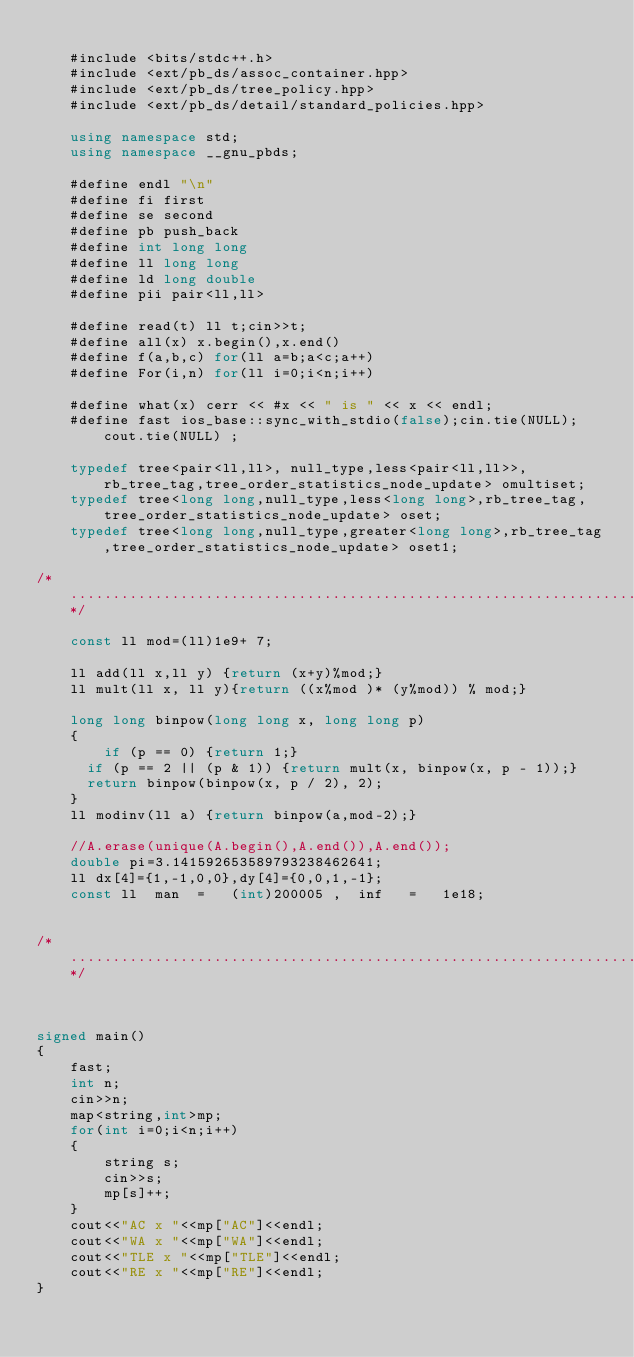<code> <loc_0><loc_0><loc_500><loc_500><_C++_> 
    #include <bits/stdc++.h>
    #include <ext/pb_ds/assoc_container.hpp>
    #include <ext/pb_ds/tree_policy.hpp>
    #include <ext/pb_ds/detail/standard_policies.hpp>
 
    using namespace std;
    using namespace __gnu_pbds;
 
    #define endl "\n"
    #define fi first
    #define se second
    #define pb push_back
    #define int long long
    #define ll long long
    #define ld long double
    #define pii pair<ll,ll>
 
    #define read(t) ll t;cin>>t;
    #define all(x) x.begin(),x.end()
    #define f(a,b,c) for(ll a=b;a<c;a++)
    #define For(i,n) for(ll i=0;i<n;i++)
 
    #define what(x) cerr << #x << " is " << x << endl;
    #define fast ios_base::sync_with_stdio(false);cin.tie(NULL);cout.tie(NULL) ;
 
    typedef tree<pair<ll,ll>, null_type,less<pair<ll,ll>>, rb_tree_tag,tree_order_statistics_node_update> omultiset;
    typedef tree<long long,null_type,less<long long>,rb_tree_tag,tree_order_statistics_node_update> oset;
    typedef tree<long long,null_type,greater<long long>,rb_tree_tag,tree_order_statistics_node_update> oset1;
 
/*.....................................................................................................................*/
 
    const ll mod=(ll)1e9+ 7;
 
    ll add(ll x,ll y) {return (x+y)%mod;}
    ll mult(ll x, ll y){return ((x%mod )* (y%mod)) % mod;}
 
    long long binpow(long long x, long long p) 
    {
        if (p == 0) {return 1;} 
    	if (p == 2 || (p & 1)) {return mult(x, binpow(x, p - 1));}
    	return binpow(binpow(x, p / 2), 2);
    }
    ll modinv(ll a) {return binpow(a,mod-2);}
 
    //A.erase(unique(A.begin(),A.end()),A.end());
    double pi=3.141592653589793238462641;
    ll dx[4]={1,-1,0,0},dy[4]={0,0,1,-1};
    const ll  man  =   (int)200005 ,  inf   =   1e18;
 
 
/*......................................................................................................................*/



signed main()
{
    fast;
    int n;
    cin>>n;
    map<string,int>mp;
    for(int i=0;i<n;i++)
    {
        string s;
        cin>>s;
        mp[s]++;
    }
    cout<<"AC x "<<mp["AC"]<<endl;
    cout<<"WA x "<<mp["WA"]<<endl;
    cout<<"TLE x "<<mp["TLE"]<<endl;
    cout<<"RE x "<<mp["RE"]<<endl;
}   </code> 